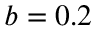<formula> <loc_0><loc_0><loc_500><loc_500>b = 0 . 2</formula> 